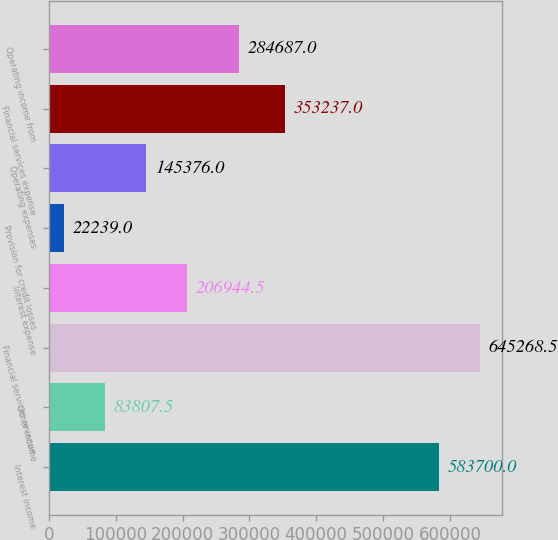<chart> <loc_0><loc_0><loc_500><loc_500><bar_chart><fcel>Interest income<fcel>Other income<fcel>Financial services revenue<fcel>Interest expense<fcel>Provision for credit losses<fcel>Operating expenses<fcel>Financial services expense<fcel>Operating income from<nl><fcel>583700<fcel>83807.5<fcel>645268<fcel>206944<fcel>22239<fcel>145376<fcel>353237<fcel>284687<nl></chart> 